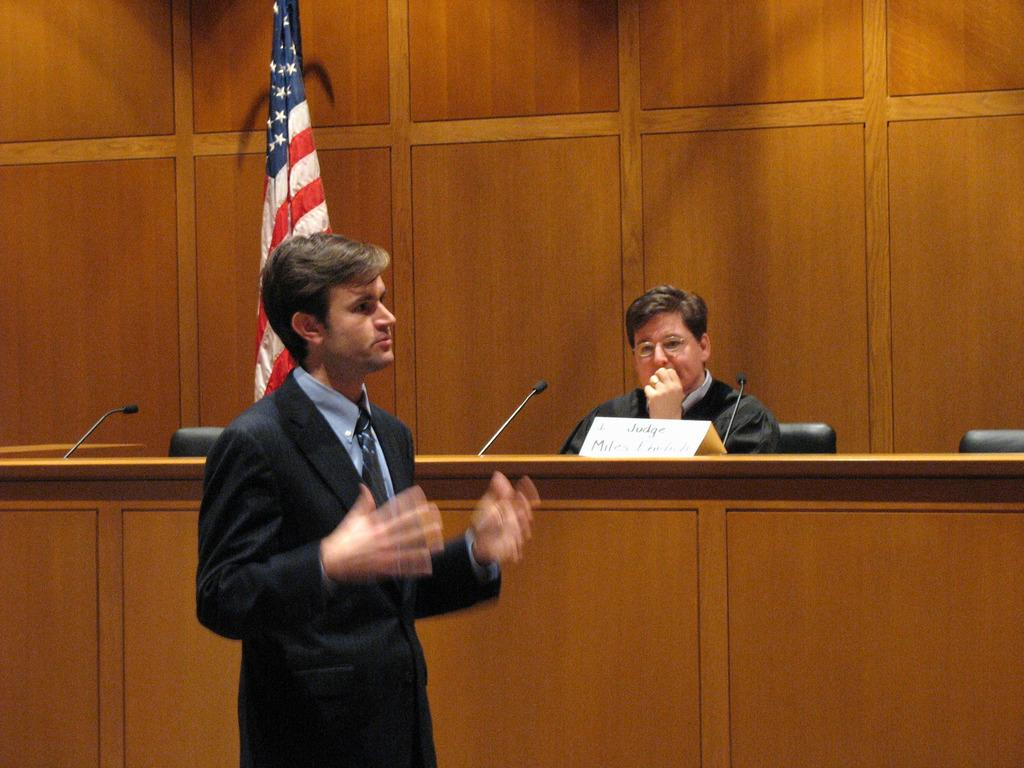What is the primary action of the person in the image? There is a person standing in the image. Can you describe the setting in the background of the image? There is a person sitting on a chair, chairs, and a flag in the background of the image. What objects are on the table in the image? There are microphones (mikes) and a name board on the table in the image. What is the lighting condition in the image? There is dark in the image. What type of pest can be seen crawling on the person in the image? There are no pests visible in the image; it features a person standing and a background with chairs and a flag. Who is the manager of the group in the image? There is no group or manager mentioned or visible in the image. 